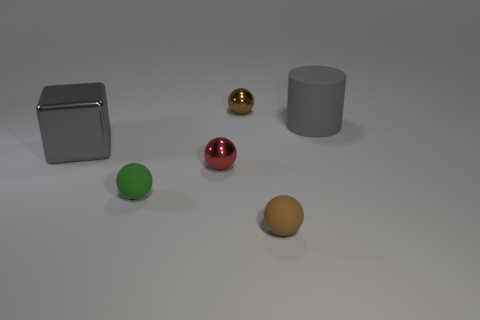What material is the large thing that is the same color as the big block?
Your answer should be very brief. Rubber. There is a tiny brown thing that is behind the tiny matte thing that is to the right of the green ball; is there a big gray metal thing in front of it?
Provide a succinct answer. Yes. Do the green thing and the big shiny object have the same shape?
Offer a very short reply. No. Are there fewer small green rubber spheres right of the red shiny object than small brown shiny objects?
Your answer should be compact. Yes. What is the color of the rubber sphere to the right of the rubber ball that is left of the brown matte thing that is in front of the green object?
Your response must be concise. Brown. What number of rubber things are either large gray things or green spheres?
Offer a very short reply. 2. Do the gray matte object and the gray metal object have the same size?
Give a very brief answer. Yes. Is the number of gray cubes that are in front of the matte cylinder less than the number of things behind the tiny red sphere?
Keep it short and to the point. Yes. How big is the brown rubber sphere?
Ensure brevity in your answer.  Small. How many big objects are either rubber cylinders or green shiny cylinders?
Keep it short and to the point. 1. 